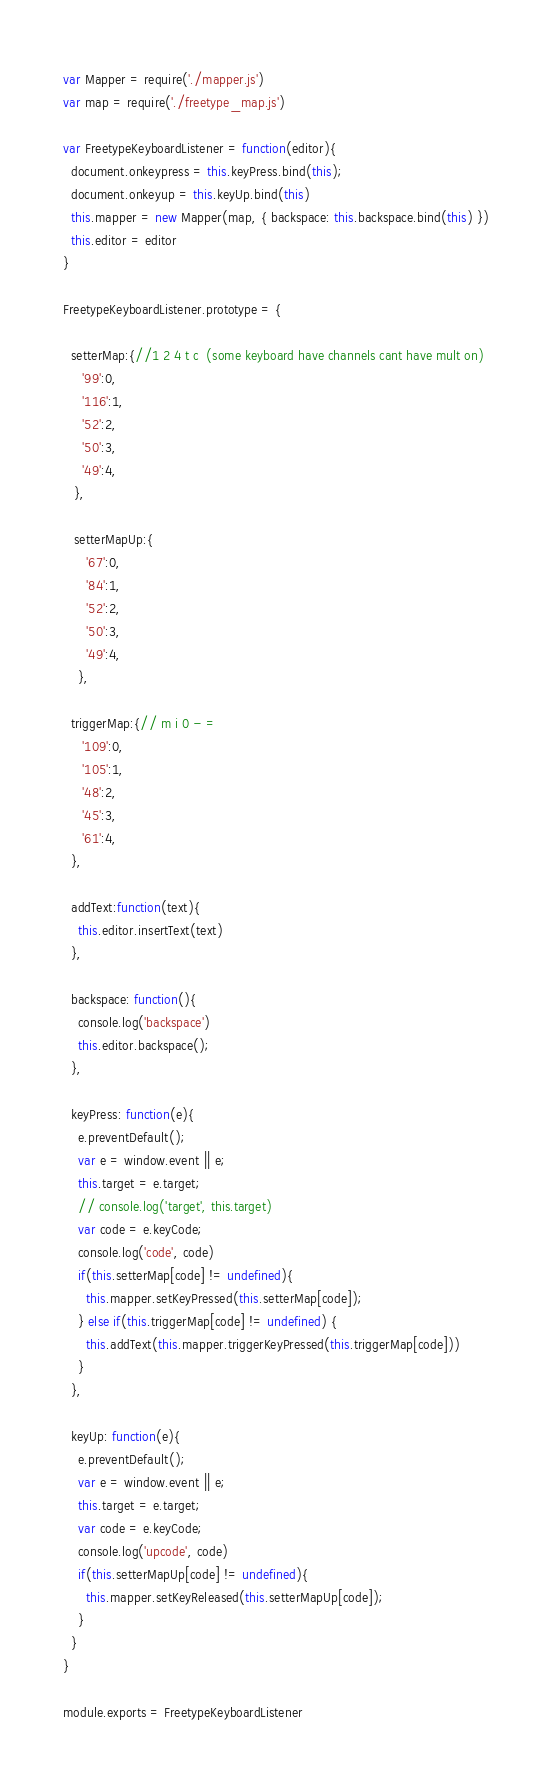Convert code to text. <code><loc_0><loc_0><loc_500><loc_500><_JavaScript_>var Mapper = require('./mapper.js')
var map = require('./freetype_map.js')

var FreetypeKeyboardListener = function(editor){
  document.onkeypress = this.keyPress.bind(this);
  document.onkeyup = this.keyUp.bind(this)
  this.mapper = new Mapper(map, { backspace: this.backspace.bind(this) })
  this.editor = editor
}

FreetypeKeyboardListener.prototype = {

  setterMap:{//1 2 4 t c  (some keyboard have channels cant have mult on)
     '99':0,
     '116':1,
     '52':2,
     '50':3,
     '49':4,
   },

   setterMapUp:{
      '67':0,
      '84':1,
      '52':2,
      '50':3,
      '49':4,
    },

  triggerMap:{// m i 0 - =
     '109':0,
     '105':1,
     '48':2,
     '45':3,
     '61':4,
  },

  addText:function(text){
    this.editor.insertText(text)
  },

  backspace: function(){
    console.log('backspace')
    this.editor.backspace();
  },

  keyPress: function(e){
    e.preventDefault();
    var e = window.event || e;
    this.target = e.target;
    // console.log('target', this.target)
    var code = e.keyCode;
    console.log('code', code)
    if(this.setterMap[code] != undefined){
      this.mapper.setKeyPressed(this.setterMap[code]);
    } else if(this.triggerMap[code] != undefined) {
      this.addText(this.mapper.triggerKeyPressed(this.triggerMap[code]))
    }
  },

  keyUp: function(e){
    e.preventDefault();
    var e = window.event || e;
    this.target = e.target;
    var code = e.keyCode;
    console.log('upcode', code)
    if(this.setterMapUp[code] != undefined){
      this.mapper.setKeyReleased(this.setterMapUp[code]);
    }
  }
}

module.exports = FreetypeKeyboardListener
</code> 